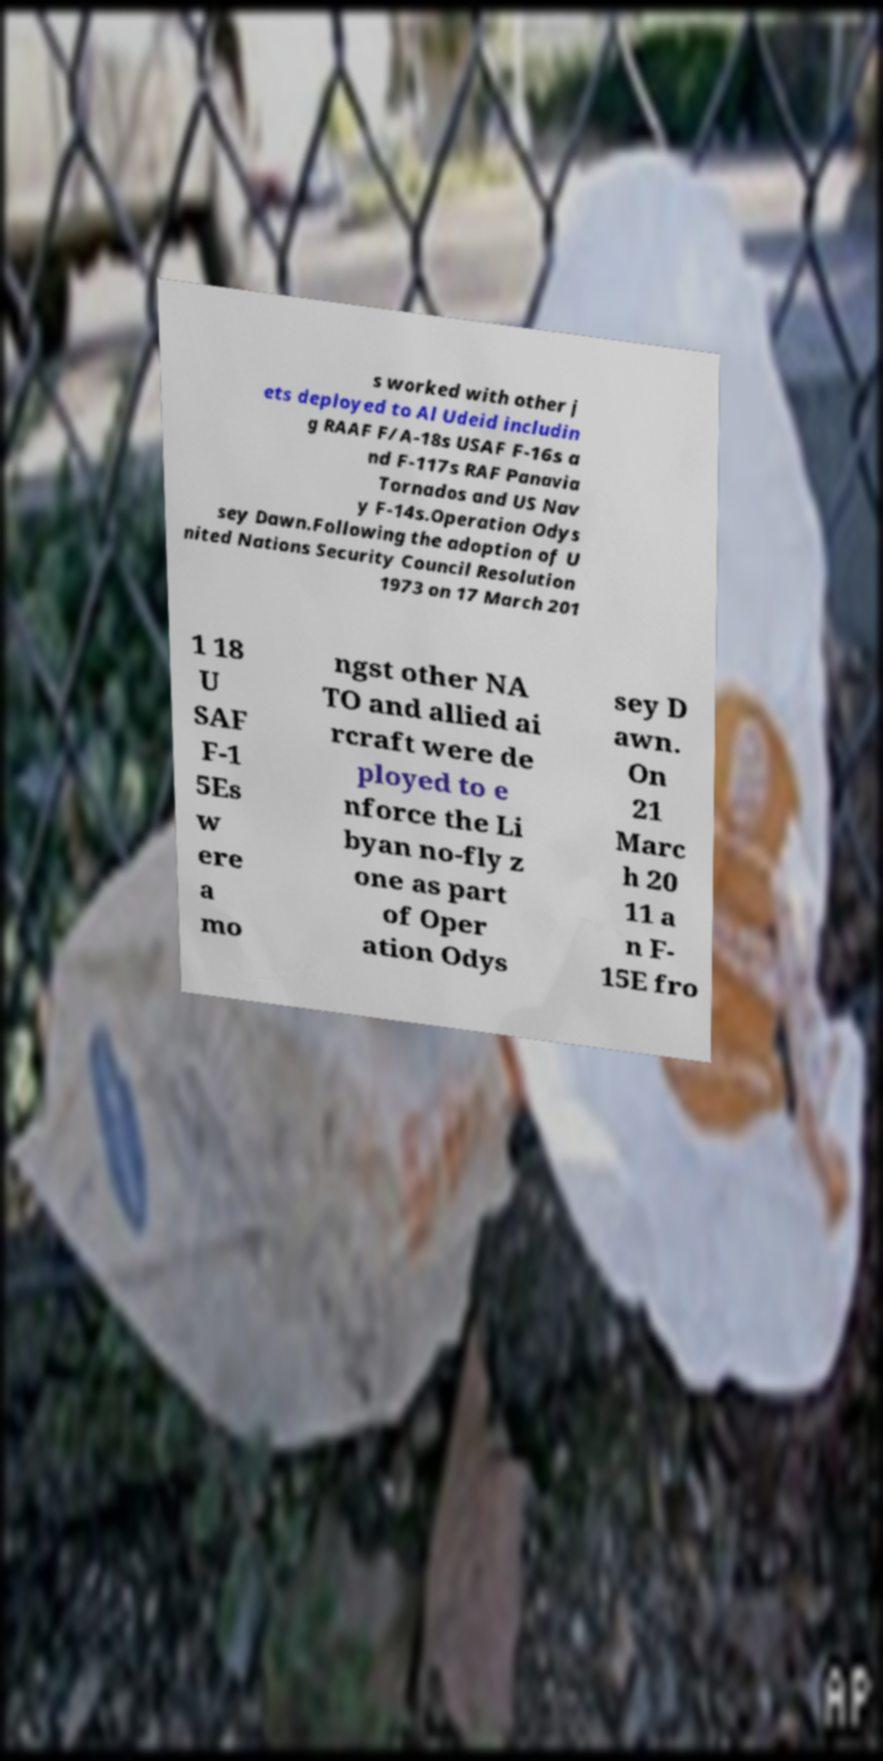For documentation purposes, I need the text within this image transcribed. Could you provide that? s worked with other j ets deployed to Al Udeid includin g RAAF F/A-18s USAF F-16s a nd F-117s RAF Panavia Tornados and US Nav y F-14s.Operation Odys sey Dawn.Following the adoption of U nited Nations Security Council Resolution 1973 on 17 March 201 1 18 U SAF F-1 5Es w ere a mo ngst other NA TO and allied ai rcraft were de ployed to e nforce the Li byan no-fly z one as part of Oper ation Odys sey D awn. On 21 Marc h 20 11 a n F- 15E fro 